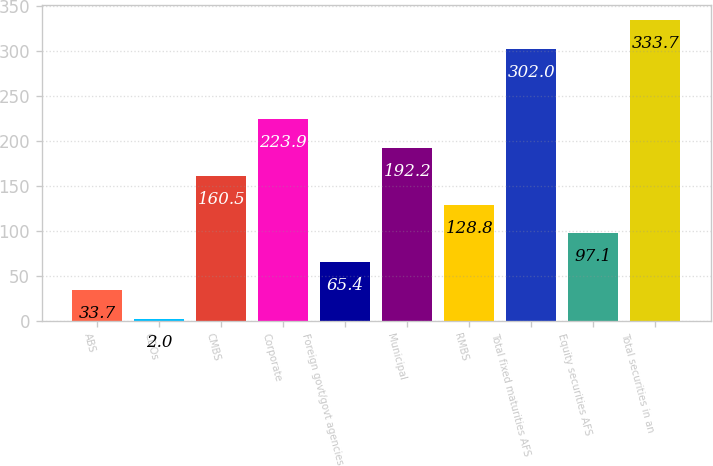Convert chart to OTSL. <chart><loc_0><loc_0><loc_500><loc_500><bar_chart><fcel>ABS<fcel>CDOs<fcel>CMBS<fcel>Corporate<fcel>Foreign govt/govt agencies<fcel>Municipal<fcel>RMBS<fcel>Total fixed maturities AFS<fcel>Equity securities AFS<fcel>Total securities in an<nl><fcel>33.7<fcel>2<fcel>160.5<fcel>223.9<fcel>65.4<fcel>192.2<fcel>128.8<fcel>302<fcel>97.1<fcel>333.7<nl></chart> 